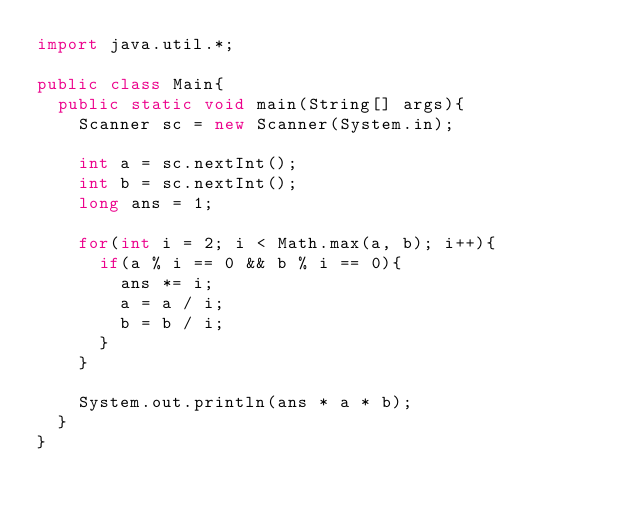<code> <loc_0><loc_0><loc_500><loc_500><_Java_>import java.util.*;

public class Main{
  public static void main(String[] args){
    Scanner sc = new Scanner(System.in);

    int a = sc.nextInt();
    int b = sc.nextInt();
    long ans = 1;

    for(int i = 2; i < Math.max(a, b); i++){
      if(a % i == 0 && b % i == 0){
        ans *= i;
        a = a / i;
        b = b / i;
      }
    }

    System.out.println(ans * a * b);
  }
}
</code> 